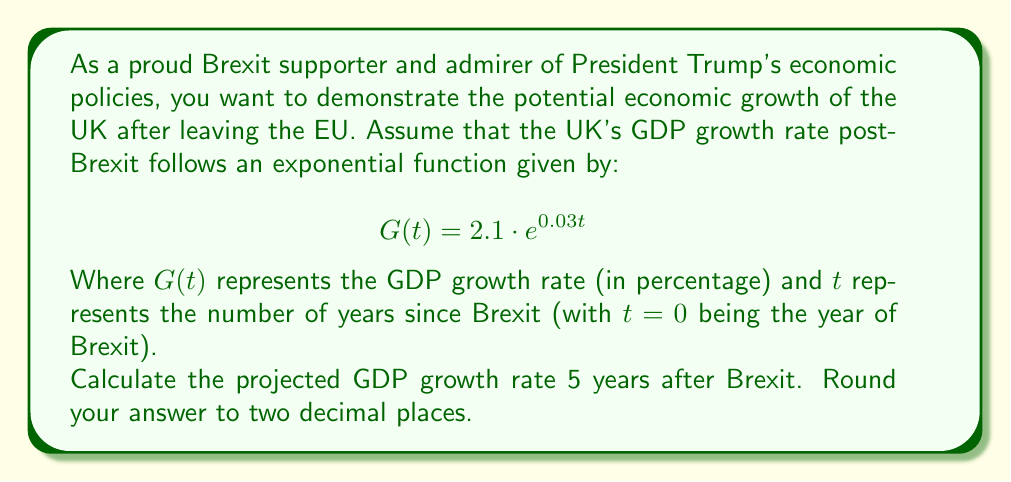What is the answer to this math problem? To solve this problem, we need to use the given exponential function and substitute the appropriate value for $t$.

1. The function is given as:
   $$G(t) = 2.1 \cdot e^{0.03t}$$

2. We want to find the GDP growth rate 5 years after Brexit, so we substitute $t=5$:
   $$G(5) = 2.1 \cdot e^{0.03 \cdot 5}$$

3. Simplify the exponent:
   $$G(5) = 2.1 \cdot e^{0.15}$$

4. Calculate $e^{0.15}$ using a calculator:
   $$e^{0.15} \approx 1.1618$$

5. Multiply by 2.1:
   $$G(5) = 2.1 \cdot 1.1618 \approx 2.43978$$

6. Round to two decimal places:
   $$G(5) \approx 2.44$$

Therefore, the projected GDP growth rate 5 years after Brexit is approximately 2.44%.
Answer: 2.44% 